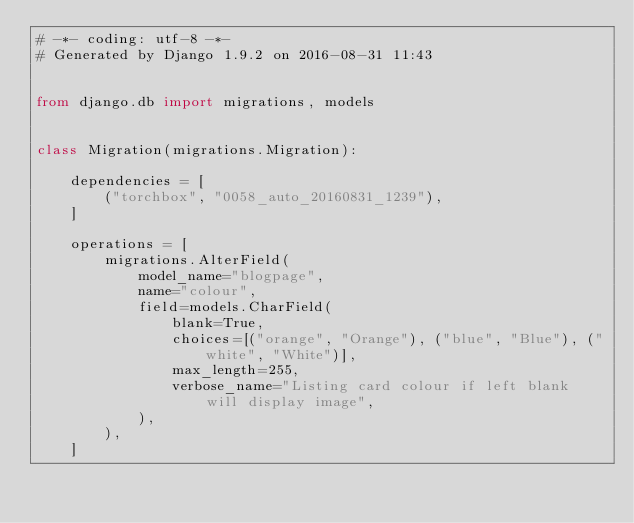<code> <loc_0><loc_0><loc_500><loc_500><_Python_># -*- coding: utf-8 -*-
# Generated by Django 1.9.2 on 2016-08-31 11:43


from django.db import migrations, models


class Migration(migrations.Migration):

    dependencies = [
        ("torchbox", "0058_auto_20160831_1239"),
    ]

    operations = [
        migrations.AlterField(
            model_name="blogpage",
            name="colour",
            field=models.CharField(
                blank=True,
                choices=[("orange", "Orange"), ("blue", "Blue"), ("white", "White")],
                max_length=255,
                verbose_name="Listing card colour if left blank will display image",
            ),
        ),
    ]
</code> 